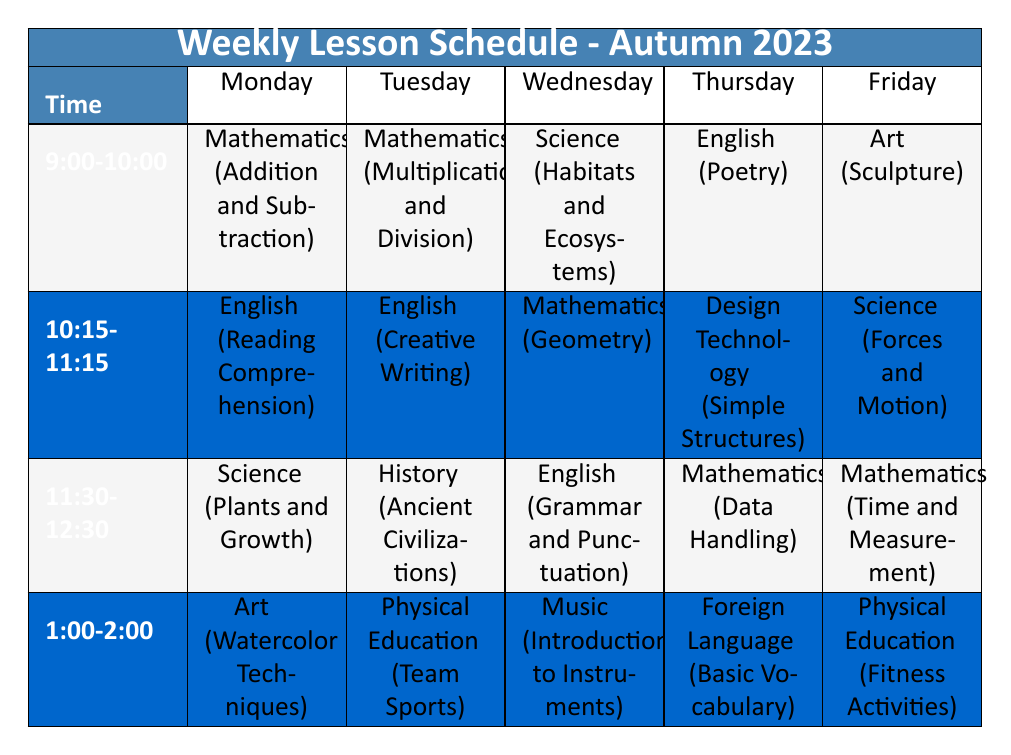What subject is taught at 9:00 on Wednesday? The table shows the subjects scheduled for each day at specific times. On Wednesday at 9:00, the subject listed is Science.
Answer: Science Which subject has its lesson on Thursday from 1:00 to 2:00? Referring to the table, on Thursday at 1:00, the subject is Foreign Language.
Answer: Foreign Language How many subjects are taught on Tuesday? The table indicates that there are four subjects listed for Tuesday, which are Mathematics, English, History, and Physical Education.
Answer: 4 Is Art taught more than once a week? Looking at the table, Art is scheduled once on Monday and once on Friday. Therefore, it is not taught more than once a week.
Answer: No What is the topic of Mathematics on Friday, and what resources are required? Under the Friday section, the topic for Mathematics is Time and Measurement, and the resources listed are Clocks and Measuring Tools.
Answer: Time and Measurement; Clocks, Measuring Tools Add the total number of different subjects taught on Friday and Monday. The total subjects on Monday are four (Mathematics, English, Science, Art) and on Friday are four (Art, Science, Mathematics, Physical Education). Adding both gives 4 + 4 = 8.
Answer: 8 Which day includes a lesson on 'Grammar and Punctuation'? Checking the table, 'Grammar and Punctuation' is listed under the English subject on Wednesday from 11:30 to 12:30.
Answer: Wednesday How many subjects involve physical activity during the week? There are two subjects related to physical activity: Physical Education on Tuesday (Team Sports) and Friday (Fitness Activities). Thus, the total is 2.
Answer: 2 What is the time slot when Design Technology is taught? According to the table, Design Technology is taught on Thursday from 10:15 to 11:15.
Answer: 10:15 to 11:15 